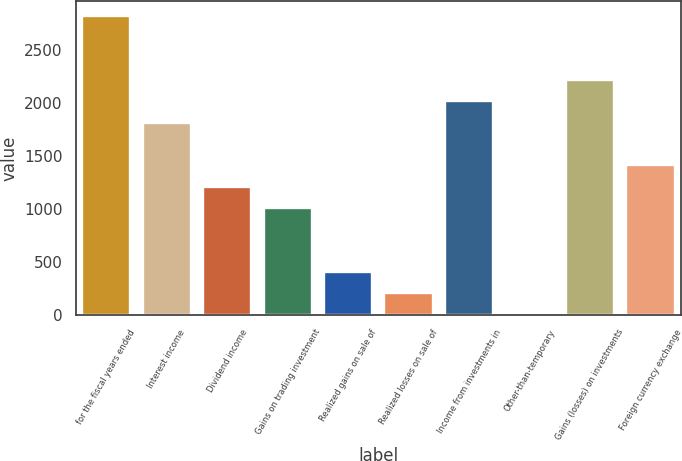Convert chart to OTSL. <chart><loc_0><loc_0><loc_500><loc_500><bar_chart><fcel>for the fiscal years ended<fcel>Interest income<fcel>Dividend income<fcel>Gains on trading investment<fcel>Realized gains on sale of<fcel>Realized losses on sale of<fcel>Income from investments in<fcel>Other-than-temporary<fcel>Gains (losses) on investments<fcel>Foreign currency exchange<nl><fcel>2823.48<fcel>1815.38<fcel>1210.52<fcel>1008.9<fcel>404.04<fcel>202.42<fcel>2017<fcel>0.8<fcel>2218.62<fcel>1412.14<nl></chart> 